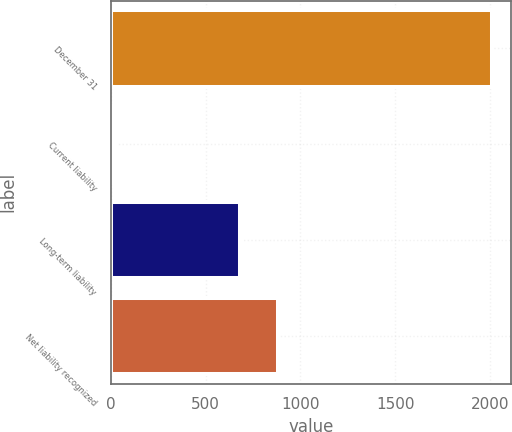Convert chart. <chart><loc_0><loc_0><loc_500><loc_500><bar_chart><fcel>December 31<fcel>Current liability<fcel>Long-term liability<fcel>Net liability recognized<nl><fcel>2010<fcel>21<fcel>681<fcel>879.9<nl></chart> 